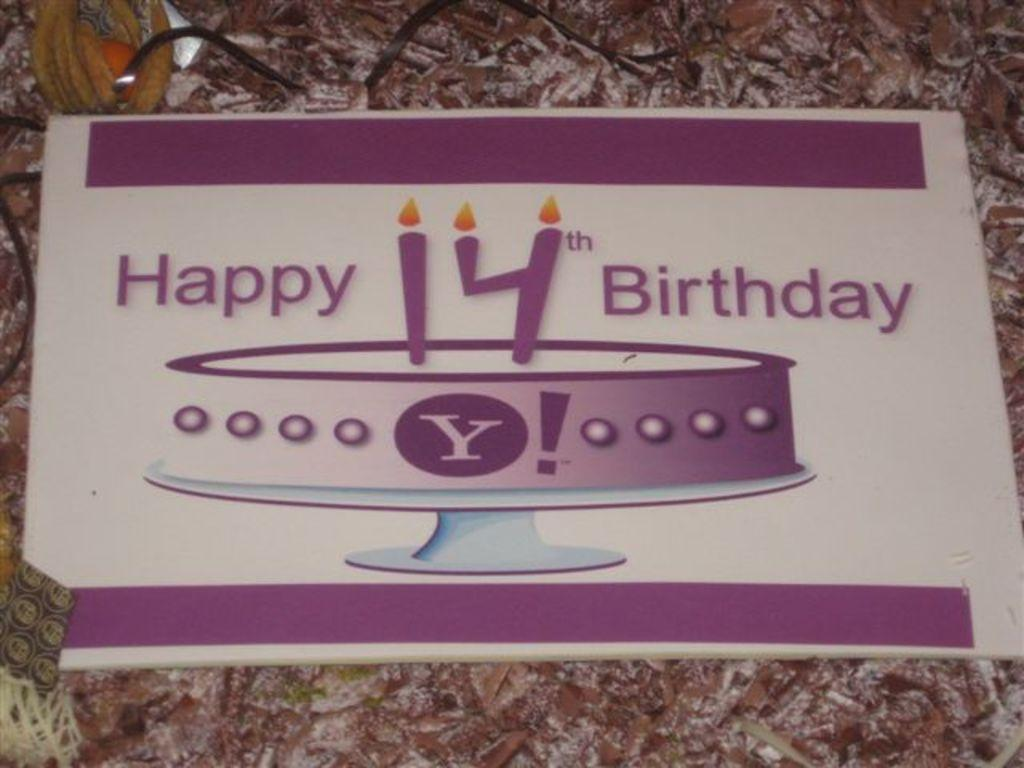What is the color of the main object in the image? The main object in the image is white. What is written on the white object? There is writing on the white object. What image can be seen on the white object? There is an image of a cake on the white object. Where is the tiger located in the image? There is no tiger present in the image. What type of plate is used to serve the cake in the image? The image does not show a plate, as it only features a white object with writing and an image of a cake. 